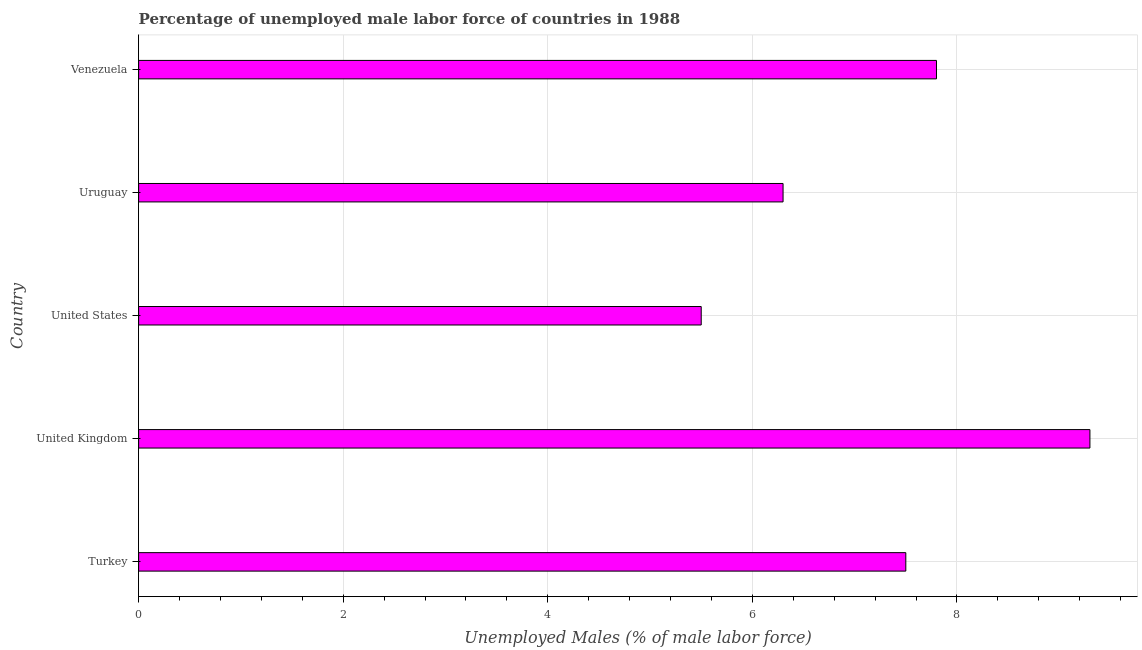Does the graph contain any zero values?
Provide a succinct answer. No. Does the graph contain grids?
Provide a short and direct response. Yes. What is the title of the graph?
Your response must be concise. Percentage of unemployed male labor force of countries in 1988. What is the label or title of the X-axis?
Make the answer very short. Unemployed Males (% of male labor force). What is the total unemployed male labour force in Turkey?
Make the answer very short. 7.5. Across all countries, what is the maximum total unemployed male labour force?
Your answer should be compact. 9.3. Across all countries, what is the minimum total unemployed male labour force?
Your answer should be compact. 5.5. In which country was the total unemployed male labour force maximum?
Keep it short and to the point. United Kingdom. What is the sum of the total unemployed male labour force?
Ensure brevity in your answer.  36.4. What is the difference between the total unemployed male labour force in United Kingdom and Venezuela?
Your answer should be compact. 1.5. What is the average total unemployed male labour force per country?
Your response must be concise. 7.28. What is the median total unemployed male labour force?
Your response must be concise. 7.5. In how many countries, is the total unemployed male labour force greater than 8.4 %?
Provide a succinct answer. 1. What is the ratio of the total unemployed male labour force in Turkey to that in Uruguay?
Provide a short and direct response. 1.19. Is the total unemployed male labour force in Turkey less than that in United States?
Give a very brief answer. No. What is the difference between the highest and the second highest total unemployed male labour force?
Your answer should be very brief. 1.5. In how many countries, is the total unemployed male labour force greater than the average total unemployed male labour force taken over all countries?
Give a very brief answer. 3. Are all the bars in the graph horizontal?
Your response must be concise. Yes. What is the difference between two consecutive major ticks on the X-axis?
Keep it short and to the point. 2. What is the Unemployed Males (% of male labor force) of United Kingdom?
Make the answer very short. 9.3. What is the Unemployed Males (% of male labor force) of United States?
Make the answer very short. 5.5. What is the Unemployed Males (% of male labor force) in Uruguay?
Keep it short and to the point. 6.3. What is the Unemployed Males (% of male labor force) of Venezuela?
Ensure brevity in your answer.  7.8. What is the difference between the Unemployed Males (% of male labor force) in Turkey and Venezuela?
Keep it short and to the point. -0.3. What is the difference between the Unemployed Males (% of male labor force) in United Kingdom and Uruguay?
Provide a succinct answer. 3. What is the difference between the Unemployed Males (% of male labor force) in United States and Uruguay?
Your answer should be very brief. -0.8. What is the ratio of the Unemployed Males (% of male labor force) in Turkey to that in United Kingdom?
Offer a terse response. 0.81. What is the ratio of the Unemployed Males (% of male labor force) in Turkey to that in United States?
Your response must be concise. 1.36. What is the ratio of the Unemployed Males (% of male labor force) in Turkey to that in Uruguay?
Offer a terse response. 1.19. What is the ratio of the Unemployed Males (% of male labor force) in Turkey to that in Venezuela?
Offer a very short reply. 0.96. What is the ratio of the Unemployed Males (% of male labor force) in United Kingdom to that in United States?
Offer a very short reply. 1.69. What is the ratio of the Unemployed Males (% of male labor force) in United Kingdom to that in Uruguay?
Keep it short and to the point. 1.48. What is the ratio of the Unemployed Males (% of male labor force) in United Kingdom to that in Venezuela?
Offer a very short reply. 1.19. What is the ratio of the Unemployed Males (% of male labor force) in United States to that in Uruguay?
Offer a very short reply. 0.87. What is the ratio of the Unemployed Males (% of male labor force) in United States to that in Venezuela?
Your answer should be compact. 0.7. What is the ratio of the Unemployed Males (% of male labor force) in Uruguay to that in Venezuela?
Provide a short and direct response. 0.81. 